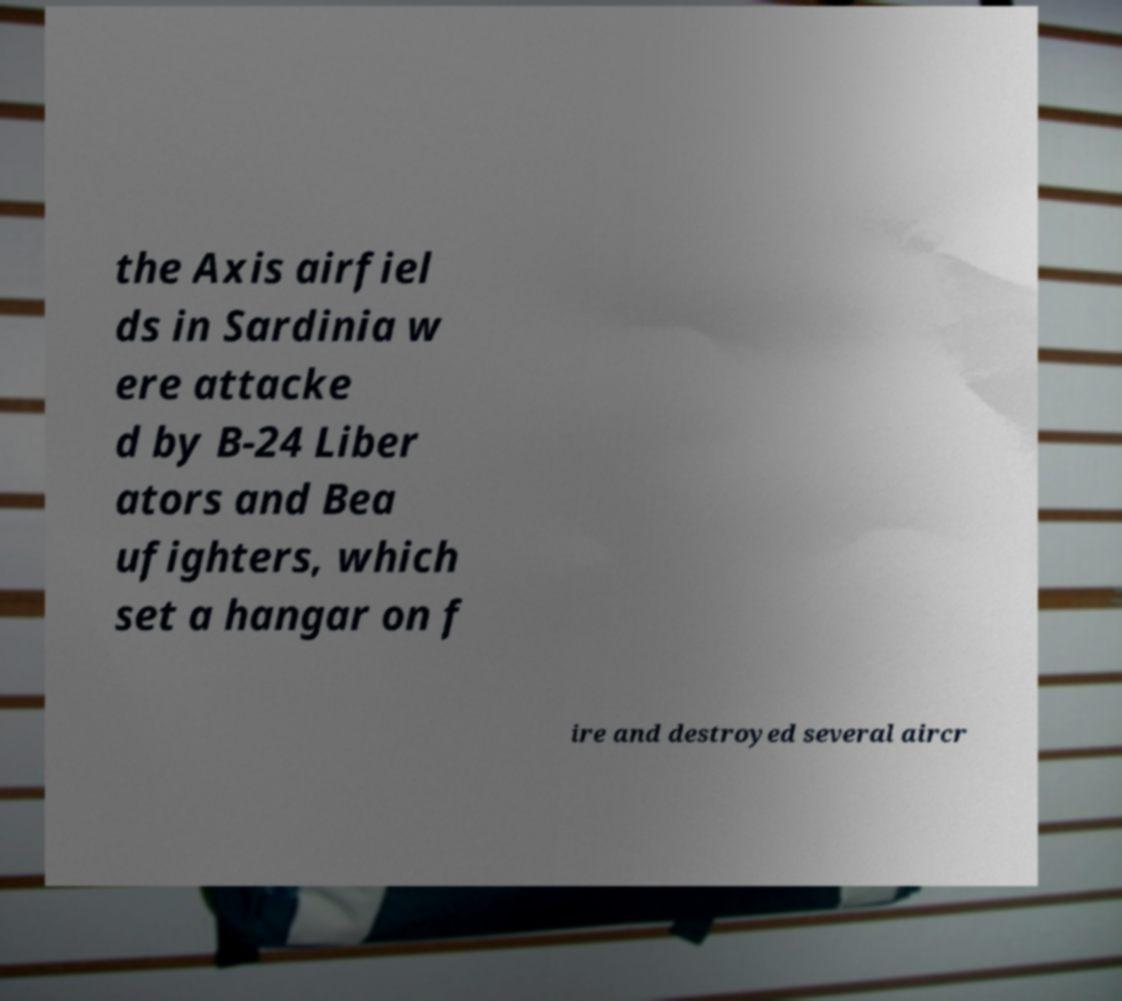Please read and relay the text visible in this image. What does it say? the Axis airfiel ds in Sardinia w ere attacke d by B-24 Liber ators and Bea ufighters, which set a hangar on f ire and destroyed several aircr 